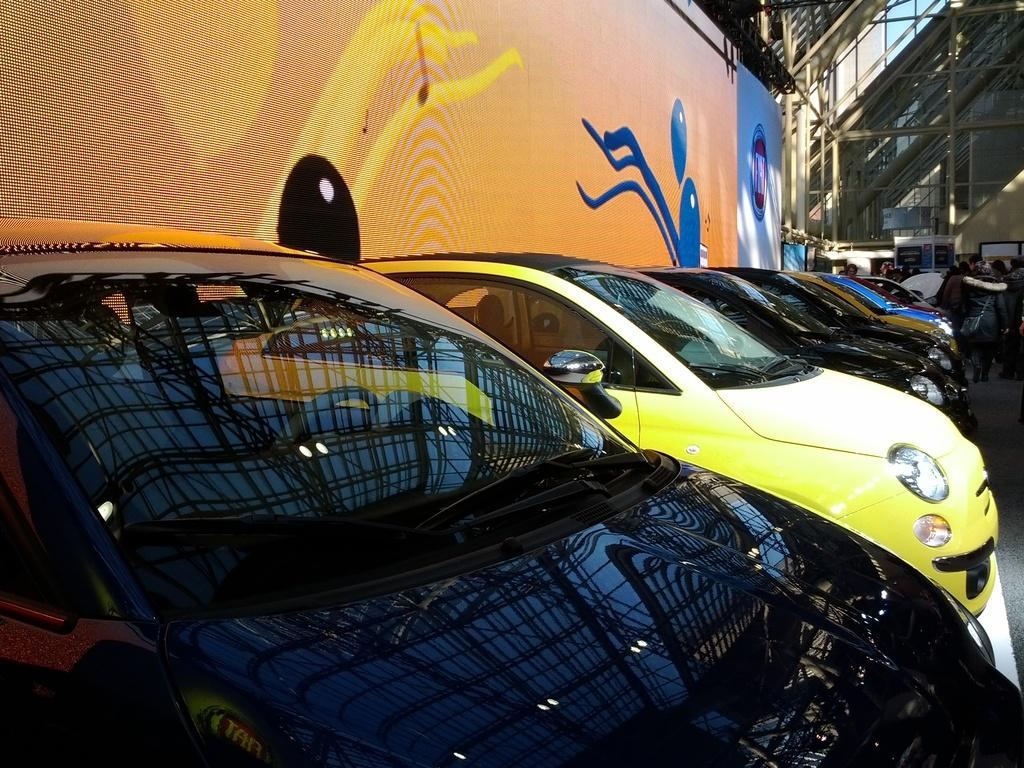What can be seen on the side of the image? There are cars parked on the side in the image. What is present in the background of the image? There is a banner, stairs, and some unspecified objects visible in the background of the image. Can you describe the banner in the image? The banner has orange and blue colors. What architectural feature is visible in the background of the image? There are stairs visible in the background of the image. How many dolls are present in the image? There are no dolls present in the image. What type of test is being conducted in the image? There is no test being conducted in the image. 